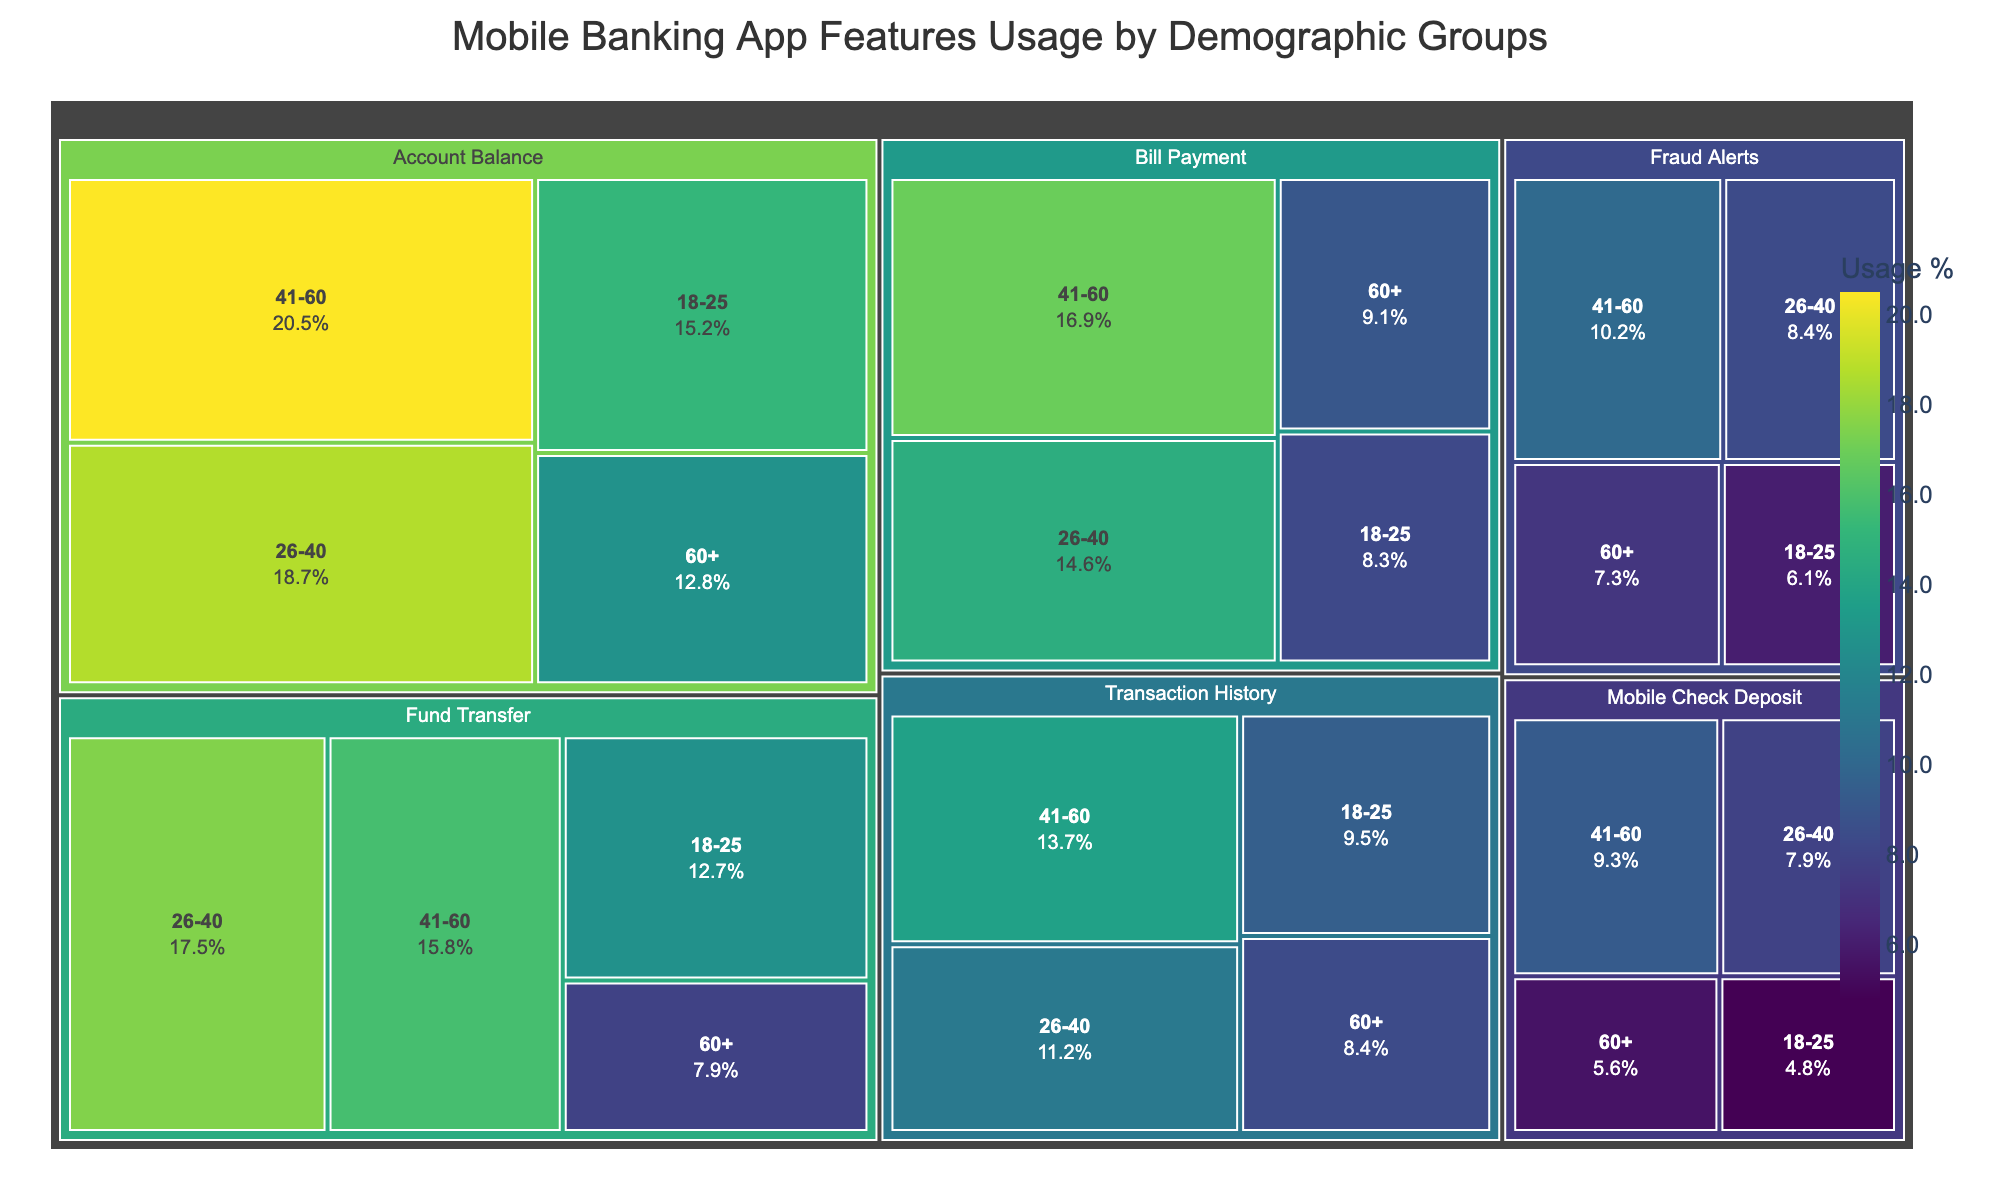What is the title of the Treemap? The title is displayed at the top of the figure, and it indicates the overall purpose of the visualization.
Answer: Mobile Banking App Features Usage by Demographic Groups Which feature has the highest usage percentage for the age group 41-60? From the treemap, look for the largest tile within the 41-60 age group and identify the feature.
Answer: Account Balance How does the usage of the Bill Payment feature compare between the 26-40 and 60+ age groups? Locate the tiles for Bill Payment in the 26-40 and 60+ age groups, and compare the percentages.
Answer: Higher in 26-40 What is the combined usage percentage of the Mobile Check Deposit feature for all age groups? Sum the usage percentages for Mobile Check Deposit across all age groups: 4.8% + 7.9% + 9.3% + 5.6%.
Answer: 27.6% Which demographic group uses the Account Balance feature the least? Identify the smallest tile representing Account Balance across all age groups in the treemap.
Answer: 60+ What is the average usage percentage for Fraud Alerts across all demographic groups? Sum the usage percentages for Fraud Alerts and divide by the number of demographic groups: (6.1 + 8.4 + 10.2 + 7.3)/4.
Answer: 8 Compare the overall usage of Fund Transfer and Bill Payment features. Which one is higher? Sum the usage percentages for each feature across all age groups and compare them: Fund Transfer (12.7% + 17.5% + 15.8% + 7.9%) vs. Bill Payment (8.3% + 14.6% + 16.9% + 9.1%).
Answer: Fund Transfer Which feature is the most popular in the 18-25 demographic group? Identify the largest tile in the 18-25 age group in the treemap.
Answer: Account Balance What is the usage difference of the Transaction History feature between the 26-40 and 60+ age groups? Subtract the usage percentage of the 60+ age group from the 26-40 age group for the Transaction History feature: 11.2% - 8.4%.
Answer: 2.8% How many tiles represent the usage of Mobile Banking App Features for the 60+ age group? Count the number of tiles corresponding to the 60+ demographic group in the treemap.
Answer: 6 